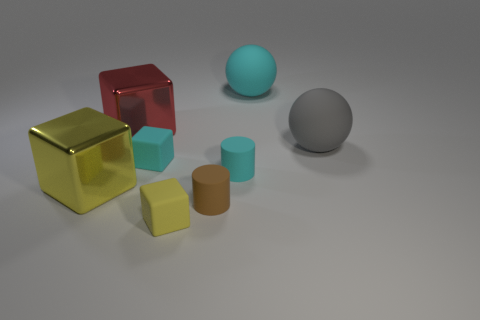What might be the intention behind this particular arrangement of shapes and colors? This image could be an exploration of form and color in a controlled environment, often used for educational purposes or to test 3D rendering techniques. The diverse shapes offer a comparison of geometry—a sphere, cylinder, and cubes—while the colors range from vibrant red and gold to muted teal and orange. It might be designed to demonstrate the interaction of light with different surfaces, or to provide a visually pleasing composition based on color theory. 